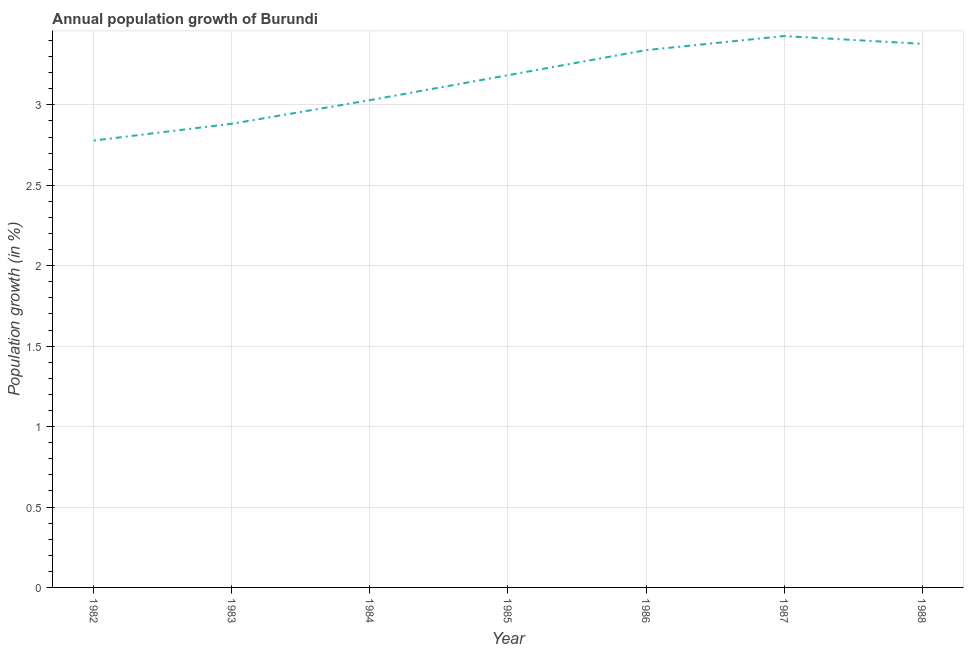What is the population growth in 1988?
Your answer should be very brief. 3.38. Across all years, what is the maximum population growth?
Your answer should be compact. 3.43. Across all years, what is the minimum population growth?
Give a very brief answer. 2.78. In which year was the population growth maximum?
Provide a succinct answer. 1987. What is the sum of the population growth?
Ensure brevity in your answer.  22.02. What is the difference between the population growth in 1985 and 1987?
Provide a short and direct response. -0.24. What is the average population growth per year?
Your response must be concise. 3.15. What is the median population growth?
Keep it short and to the point. 3.18. In how many years, is the population growth greater than 3.2 %?
Provide a short and direct response. 3. Do a majority of the years between 1986 and 1983 (inclusive) have population growth greater than 0.9 %?
Give a very brief answer. Yes. What is the ratio of the population growth in 1987 to that in 1988?
Your answer should be very brief. 1.01. What is the difference between the highest and the second highest population growth?
Give a very brief answer. 0.05. What is the difference between the highest and the lowest population growth?
Offer a very short reply. 0.65. Does the population growth monotonically increase over the years?
Provide a short and direct response. No. How many years are there in the graph?
Provide a succinct answer. 7. What is the difference between two consecutive major ticks on the Y-axis?
Give a very brief answer. 0.5. Does the graph contain any zero values?
Give a very brief answer. No. What is the title of the graph?
Your answer should be compact. Annual population growth of Burundi. What is the label or title of the X-axis?
Give a very brief answer. Year. What is the label or title of the Y-axis?
Offer a terse response. Population growth (in %). What is the Population growth (in %) in 1982?
Make the answer very short. 2.78. What is the Population growth (in %) in 1983?
Make the answer very short. 2.88. What is the Population growth (in %) in 1984?
Make the answer very short. 3.03. What is the Population growth (in %) of 1985?
Make the answer very short. 3.18. What is the Population growth (in %) in 1986?
Offer a very short reply. 3.34. What is the Population growth (in %) in 1987?
Provide a short and direct response. 3.43. What is the Population growth (in %) of 1988?
Your answer should be compact. 3.38. What is the difference between the Population growth (in %) in 1982 and 1983?
Offer a very short reply. -0.1. What is the difference between the Population growth (in %) in 1982 and 1984?
Give a very brief answer. -0.25. What is the difference between the Population growth (in %) in 1982 and 1985?
Your answer should be compact. -0.41. What is the difference between the Population growth (in %) in 1982 and 1986?
Make the answer very short. -0.56. What is the difference between the Population growth (in %) in 1982 and 1987?
Your response must be concise. -0.65. What is the difference between the Population growth (in %) in 1982 and 1988?
Your response must be concise. -0.6. What is the difference between the Population growth (in %) in 1983 and 1984?
Give a very brief answer. -0.15. What is the difference between the Population growth (in %) in 1983 and 1985?
Your answer should be compact. -0.3. What is the difference between the Population growth (in %) in 1983 and 1986?
Your response must be concise. -0.46. What is the difference between the Population growth (in %) in 1983 and 1987?
Give a very brief answer. -0.55. What is the difference between the Population growth (in %) in 1983 and 1988?
Offer a very short reply. -0.5. What is the difference between the Population growth (in %) in 1984 and 1985?
Keep it short and to the point. -0.15. What is the difference between the Population growth (in %) in 1984 and 1986?
Give a very brief answer. -0.31. What is the difference between the Population growth (in %) in 1984 and 1987?
Provide a succinct answer. -0.4. What is the difference between the Population growth (in %) in 1984 and 1988?
Offer a very short reply. -0.35. What is the difference between the Population growth (in %) in 1985 and 1986?
Offer a very short reply. -0.16. What is the difference between the Population growth (in %) in 1985 and 1987?
Provide a short and direct response. -0.24. What is the difference between the Population growth (in %) in 1985 and 1988?
Provide a succinct answer. -0.19. What is the difference between the Population growth (in %) in 1986 and 1987?
Offer a very short reply. -0.09. What is the difference between the Population growth (in %) in 1986 and 1988?
Offer a terse response. -0.04. What is the difference between the Population growth (in %) in 1987 and 1988?
Your answer should be compact. 0.05. What is the ratio of the Population growth (in %) in 1982 to that in 1983?
Offer a very short reply. 0.96. What is the ratio of the Population growth (in %) in 1982 to that in 1984?
Your answer should be compact. 0.92. What is the ratio of the Population growth (in %) in 1982 to that in 1985?
Make the answer very short. 0.87. What is the ratio of the Population growth (in %) in 1982 to that in 1986?
Your answer should be very brief. 0.83. What is the ratio of the Population growth (in %) in 1982 to that in 1987?
Offer a very short reply. 0.81. What is the ratio of the Population growth (in %) in 1982 to that in 1988?
Offer a very short reply. 0.82. What is the ratio of the Population growth (in %) in 1983 to that in 1985?
Offer a very short reply. 0.91. What is the ratio of the Population growth (in %) in 1983 to that in 1986?
Your answer should be very brief. 0.86. What is the ratio of the Population growth (in %) in 1983 to that in 1987?
Keep it short and to the point. 0.84. What is the ratio of the Population growth (in %) in 1983 to that in 1988?
Your answer should be compact. 0.85. What is the ratio of the Population growth (in %) in 1984 to that in 1985?
Your response must be concise. 0.95. What is the ratio of the Population growth (in %) in 1984 to that in 1986?
Your response must be concise. 0.91. What is the ratio of the Population growth (in %) in 1984 to that in 1987?
Ensure brevity in your answer.  0.88. What is the ratio of the Population growth (in %) in 1984 to that in 1988?
Give a very brief answer. 0.9. What is the ratio of the Population growth (in %) in 1985 to that in 1986?
Provide a short and direct response. 0.95. What is the ratio of the Population growth (in %) in 1985 to that in 1987?
Offer a terse response. 0.93. What is the ratio of the Population growth (in %) in 1985 to that in 1988?
Keep it short and to the point. 0.94. What is the ratio of the Population growth (in %) in 1986 to that in 1987?
Ensure brevity in your answer.  0.97. What is the ratio of the Population growth (in %) in 1986 to that in 1988?
Ensure brevity in your answer.  0.99. 